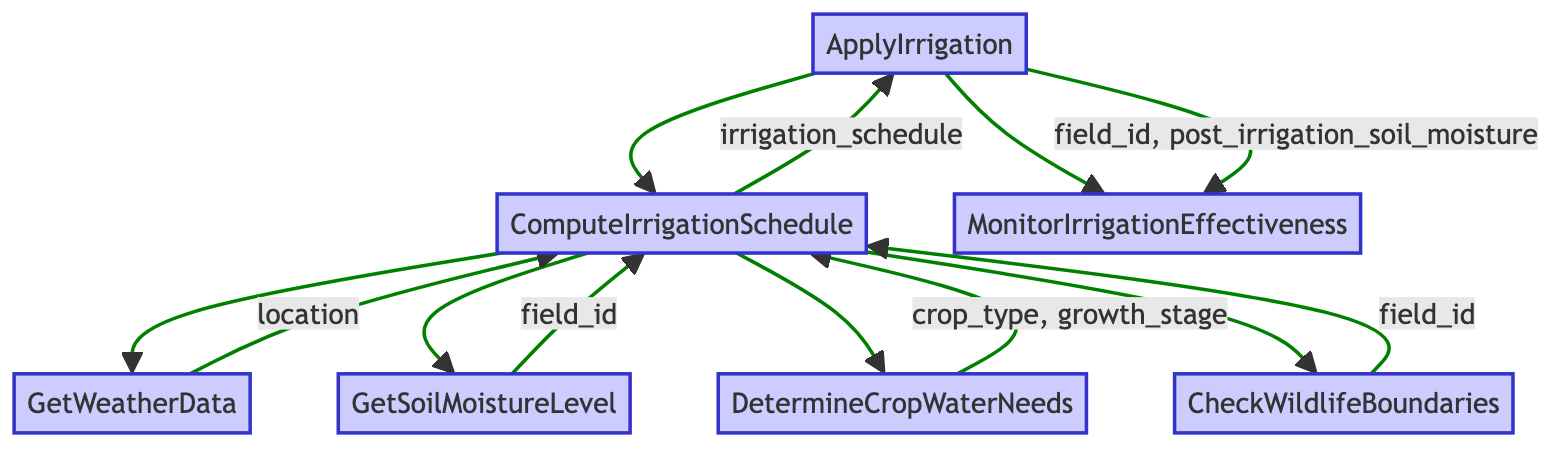What is the final action in the flowchart? The flowchart progresses upward through several steps, ultimately concluding with the action labeled "ApplyIrrigation." This is the last function invoked before the monitoring step.
Answer: ApplyIrrigation How many total functions are in the flowchart? The flowchart includes a total of seven distinct functions represented by the labeled nodes and actions, which are: ApplyIrrigation, ComputeIrrigationSchedule, GetWeatherData, GetSoilMoistureLevel, DetermineCropWaterNeeds, CheckWildlifeBoundaries, and MonitorIrrigationEffectiveness.
Answer: Seven Which function retrieves weather data? The function responsible for retrieving weather data is clearly named "GetWeatherData," as indicated by its labeling in the flowchart.
Answer: GetWeatherData What parameters does ComputeIrrigationSchedule require? The "ComputeIrrigationSchedule" function requires four parameters: weather_data, soil_moisture_level, crop_water_needs, and wildlife_boundaries, as specified by the flow diagram.
Answer: Weather data, soil moisture level, crop water needs, wildlife boundaries Which function monitors the effectiveness of irrigation? The function that evaluates the effectiveness of irrigation is labeled "MonitorIrrigationEffectiveness," which provides feedback on the successful irrigation application.
Answer: MonitorIrrigationEffectiveness What comes directly before monitoring effectiveness? The function that comes directly before "MonitorIrrigationEffectiveness" is "ApplyIrrigation." This sequence indicates that irrigation is activated first, followed by monitoring its impact.
Answer: ApplyIrrigation What determines the optimal water requirements? The function called "DetermineCropWaterNeeds" calculates the optimal water requirements, based on information about the crop type and its growth stage, as represented in the flowchart.
Answer: DetermineCropWaterNeeds In which step are wildlife boundaries checked? Wildlife boundaries are checked during the step labeled "CheckWildlifeBoundaries," which ensures that irrigation practices do not invade protected wildlife areas.
Answer: CheckWildlifeBoundaries How does ComputeIrrigationSchedule collect its data? The "ComputeIrrigationSchedule" function gathers information from several contributing functions, including GetWeatherData, GetSoilMoistureLevel, DetermineCropWaterNeeds, and CheckWildlifeBoundaries, demonstrating a comprehensive approach to scheduling.
Answer: It collects data from GetWeatherData, GetSoilMoistureLevel, DetermineCropWaterNeeds, and CheckWildlifeBoundaries 